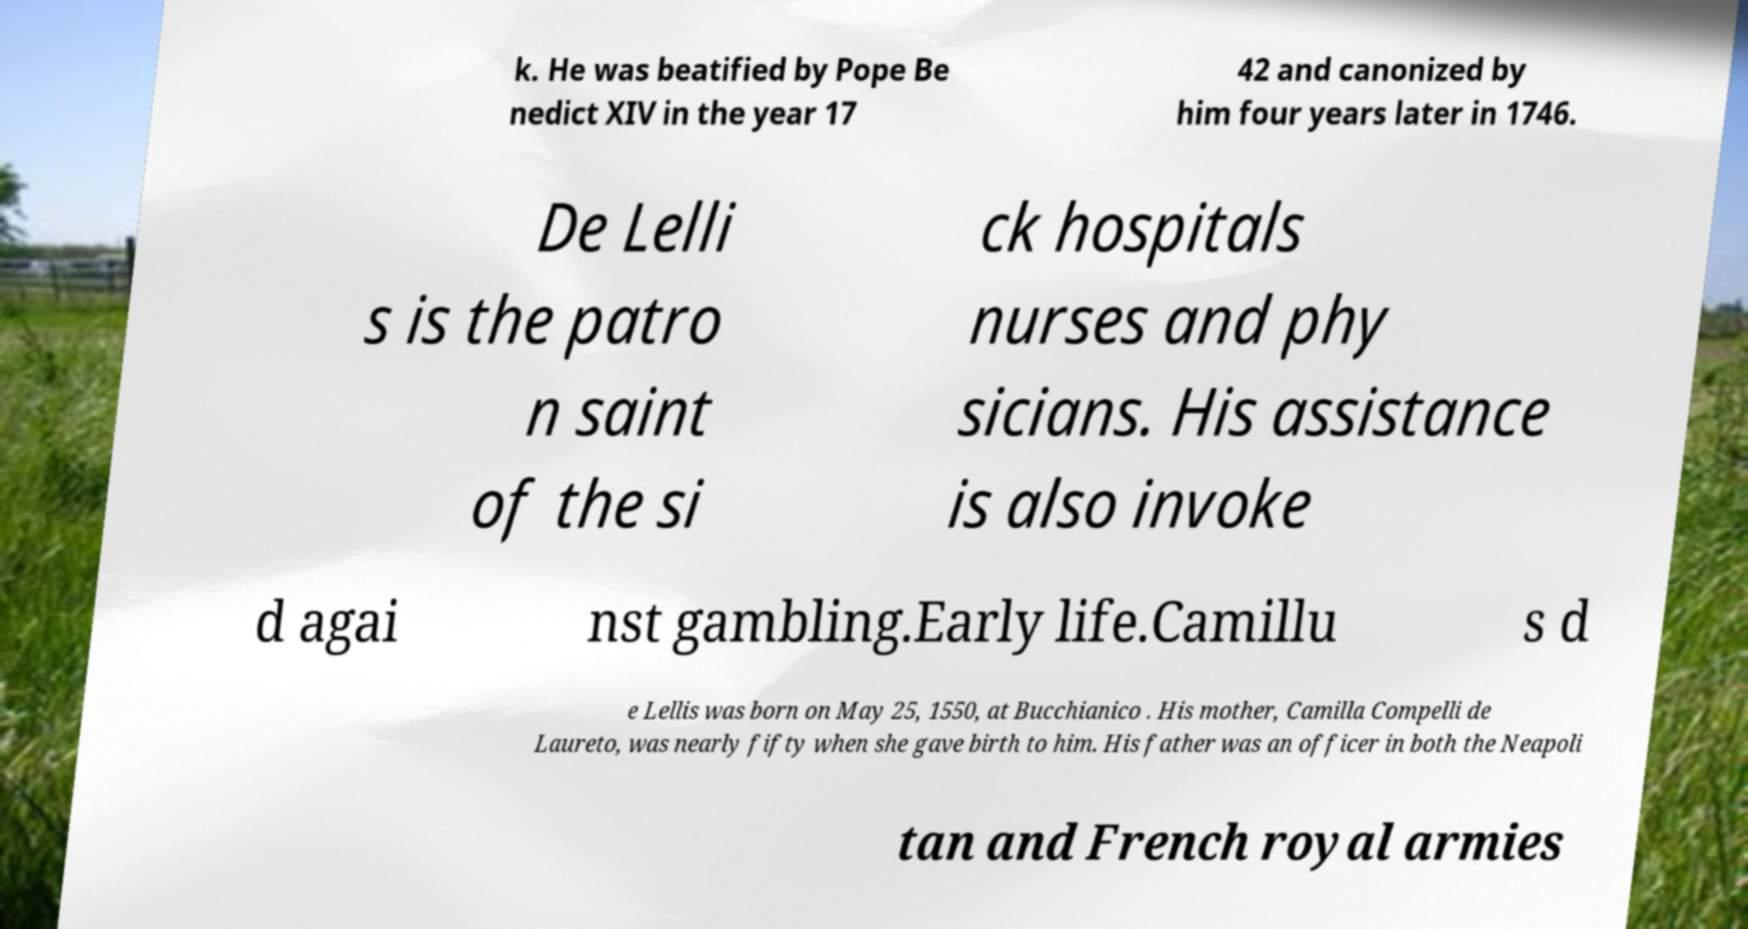Can you read and provide the text displayed in the image?This photo seems to have some interesting text. Can you extract and type it out for me? k. He was beatified by Pope Be nedict XIV in the year 17 42 and canonized by him four years later in 1746. De Lelli s is the patro n saint of the si ck hospitals nurses and phy sicians. His assistance is also invoke d agai nst gambling.Early life.Camillu s d e Lellis was born on May 25, 1550, at Bucchianico . His mother, Camilla Compelli de Laureto, was nearly fifty when she gave birth to him. His father was an officer in both the Neapoli tan and French royal armies 